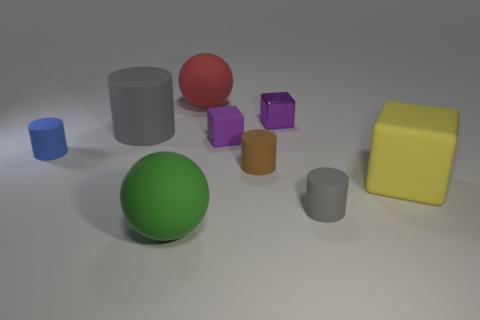There is another thing that is the same color as the shiny object; what is its size?
Your answer should be very brief. Small. Is the red object the same size as the green object?
Your response must be concise. Yes. What number of other things are there of the same shape as the purple metal object?
Provide a short and direct response. 2. There is a tiny cube behind the gray cylinder that is on the left side of the red thing; what is it made of?
Your answer should be very brief. Metal. Are there any gray objects in front of the yellow matte cube?
Make the answer very short. Yes. There is a purple rubber block; does it have the same size as the gray rubber object that is in front of the small matte cube?
Provide a short and direct response. Yes. What size is the red object that is the same shape as the big green matte thing?
Ensure brevity in your answer.  Large. Does the gray rubber object behind the brown cylinder have the same size as the blue rubber thing that is to the left of the tiny metal object?
Your answer should be compact. No. What number of small things are brown objects or purple matte blocks?
Provide a succinct answer. 2. What number of matte objects are both on the left side of the tiny gray matte object and in front of the big gray matte thing?
Give a very brief answer. 4. 